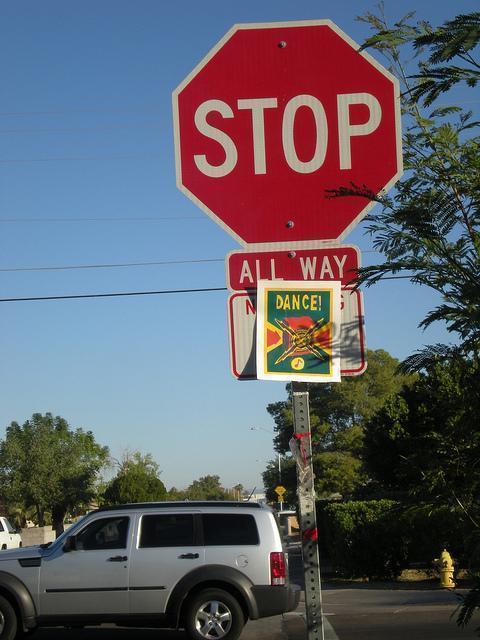How many people must stop at the intersection?
Select the accurate response from the four choices given to answer the question.
Options: Two, four, three, one. Four. 